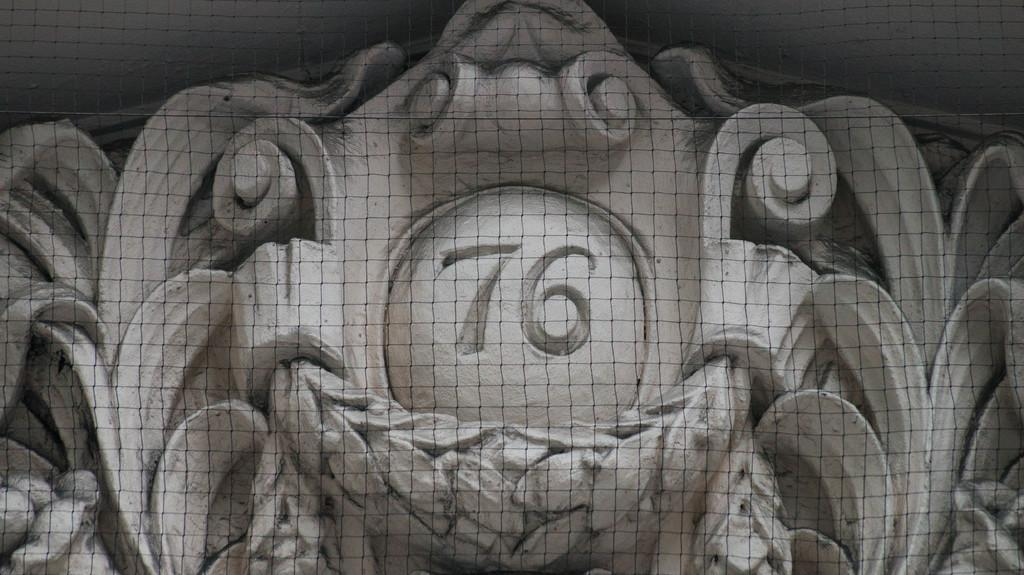What is the main subject of the picture? The main subject of the picture is a sculpture. Is there any text or numbering on the sculpture? Yes, there is a number written on the sculpture. What is located in front of the sculpture? There is a fence in front of the sculpture. How many layers of frosting are on the cake in the image? There is no cake present in the image; it features a sculpture with a number written on it and a fence in front of it. 